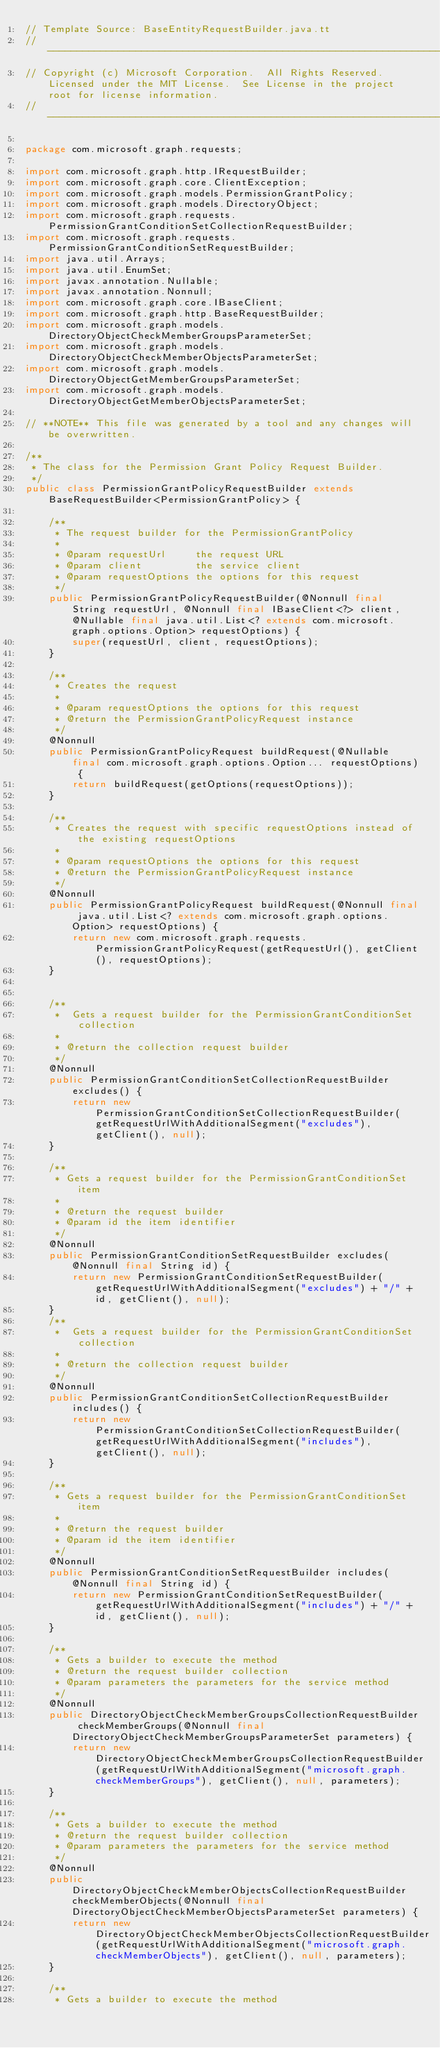<code> <loc_0><loc_0><loc_500><loc_500><_Java_>// Template Source: BaseEntityRequestBuilder.java.tt
// ------------------------------------------------------------------------------
// Copyright (c) Microsoft Corporation.  All Rights Reserved.  Licensed under the MIT License.  See License in the project root for license information.
// ------------------------------------------------------------------------------

package com.microsoft.graph.requests;

import com.microsoft.graph.http.IRequestBuilder;
import com.microsoft.graph.core.ClientException;
import com.microsoft.graph.models.PermissionGrantPolicy;
import com.microsoft.graph.models.DirectoryObject;
import com.microsoft.graph.requests.PermissionGrantConditionSetCollectionRequestBuilder;
import com.microsoft.graph.requests.PermissionGrantConditionSetRequestBuilder;
import java.util.Arrays;
import java.util.EnumSet;
import javax.annotation.Nullable;
import javax.annotation.Nonnull;
import com.microsoft.graph.core.IBaseClient;
import com.microsoft.graph.http.BaseRequestBuilder;
import com.microsoft.graph.models.DirectoryObjectCheckMemberGroupsParameterSet;
import com.microsoft.graph.models.DirectoryObjectCheckMemberObjectsParameterSet;
import com.microsoft.graph.models.DirectoryObjectGetMemberGroupsParameterSet;
import com.microsoft.graph.models.DirectoryObjectGetMemberObjectsParameterSet;

// **NOTE** This file was generated by a tool and any changes will be overwritten.

/**
 * The class for the Permission Grant Policy Request Builder.
 */
public class PermissionGrantPolicyRequestBuilder extends BaseRequestBuilder<PermissionGrantPolicy> {

    /**
     * The request builder for the PermissionGrantPolicy
     *
     * @param requestUrl     the request URL
     * @param client         the service client
     * @param requestOptions the options for this request
     */
    public PermissionGrantPolicyRequestBuilder(@Nonnull final String requestUrl, @Nonnull final IBaseClient<?> client, @Nullable final java.util.List<? extends com.microsoft.graph.options.Option> requestOptions) {
        super(requestUrl, client, requestOptions);
    }

    /**
     * Creates the request
     *
     * @param requestOptions the options for this request
     * @return the PermissionGrantPolicyRequest instance
     */
    @Nonnull
    public PermissionGrantPolicyRequest buildRequest(@Nullable final com.microsoft.graph.options.Option... requestOptions) {
        return buildRequest(getOptions(requestOptions));
    }

    /**
     * Creates the request with specific requestOptions instead of the existing requestOptions
     *
     * @param requestOptions the options for this request
     * @return the PermissionGrantPolicyRequest instance
     */
    @Nonnull
    public PermissionGrantPolicyRequest buildRequest(@Nonnull final java.util.List<? extends com.microsoft.graph.options.Option> requestOptions) {
        return new com.microsoft.graph.requests.PermissionGrantPolicyRequest(getRequestUrl(), getClient(), requestOptions);
    }


    /**
     *  Gets a request builder for the PermissionGrantConditionSet collection
     *
     * @return the collection request builder
     */
    @Nonnull
    public PermissionGrantConditionSetCollectionRequestBuilder excludes() {
        return new PermissionGrantConditionSetCollectionRequestBuilder(getRequestUrlWithAdditionalSegment("excludes"), getClient(), null);
    }

    /**
     * Gets a request builder for the PermissionGrantConditionSet item
     *
     * @return the request builder
     * @param id the item identifier
     */
    @Nonnull
    public PermissionGrantConditionSetRequestBuilder excludes(@Nonnull final String id) {
        return new PermissionGrantConditionSetRequestBuilder(getRequestUrlWithAdditionalSegment("excludes") + "/" + id, getClient(), null);
    }
    /**
     *  Gets a request builder for the PermissionGrantConditionSet collection
     *
     * @return the collection request builder
     */
    @Nonnull
    public PermissionGrantConditionSetCollectionRequestBuilder includes() {
        return new PermissionGrantConditionSetCollectionRequestBuilder(getRequestUrlWithAdditionalSegment("includes"), getClient(), null);
    }

    /**
     * Gets a request builder for the PermissionGrantConditionSet item
     *
     * @return the request builder
     * @param id the item identifier
     */
    @Nonnull
    public PermissionGrantConditionSetRequestBuilder includes(@Nonnull final String id) {
        return new PermissionGrantConditionSetRequestBuilder(getRequestUrlWithAdditionalSegment("includes") + "/" + id, getClient(), null);
    }

    /**
     * Gets a builder to execute the method
     * @return the request builder collection
     * @param parameters the parameters for the service method
     */
    @Nonnull
    public DirectoryObjectCheckMemberGroupsCollectionRequestBuilder checkMemberGroups(@Nonnull final DirectoryObjectCheckMemberGroupsParameterSet parameters) {
        return new DirectoryObjectCheckMemberGroupsCollectionRequestBuilder(getRequestUrlWithAdditionalSegment("microsoft.graph.checkMemberGroups"), getClient(), null, parameters);
    }

    /**
     * Gets a builder to execute the method
     * @return the request builder collection
     * @param parameters the parameters for the service method
     */
    @Nonnull
    public DirectoryObjectCheckMemberObjectsCollectionRequestBuilder checkMemberObjects(@Nonnull final DirectoryObjectCheckMemberObjectsParameterSet parameters) {
        return new DirectoryObjectCheckMemberObjectsCollectionRequestBuilder(getRequestUrlWithAdditionalSegment("microsoft.graph.checkMemberObjects"), getClient(), null, parameters);
    }

    /**
     * Gets a builder to execute the method</code> 